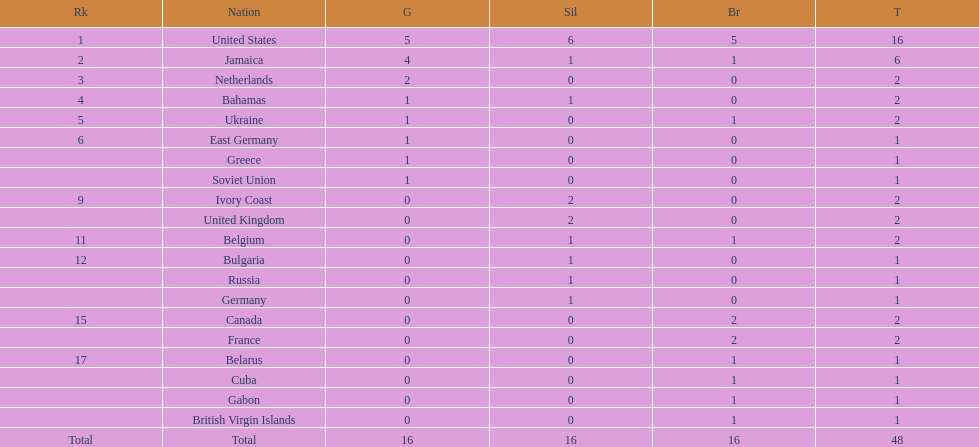Which nations took home at least one gold medal in the 60 metres competition? United States, Jamaica, Netherlands, Bahamas, Ukraine, East Germany, Greece, Soviet Union. Of these nations, which one won the most gold medals? United States. 